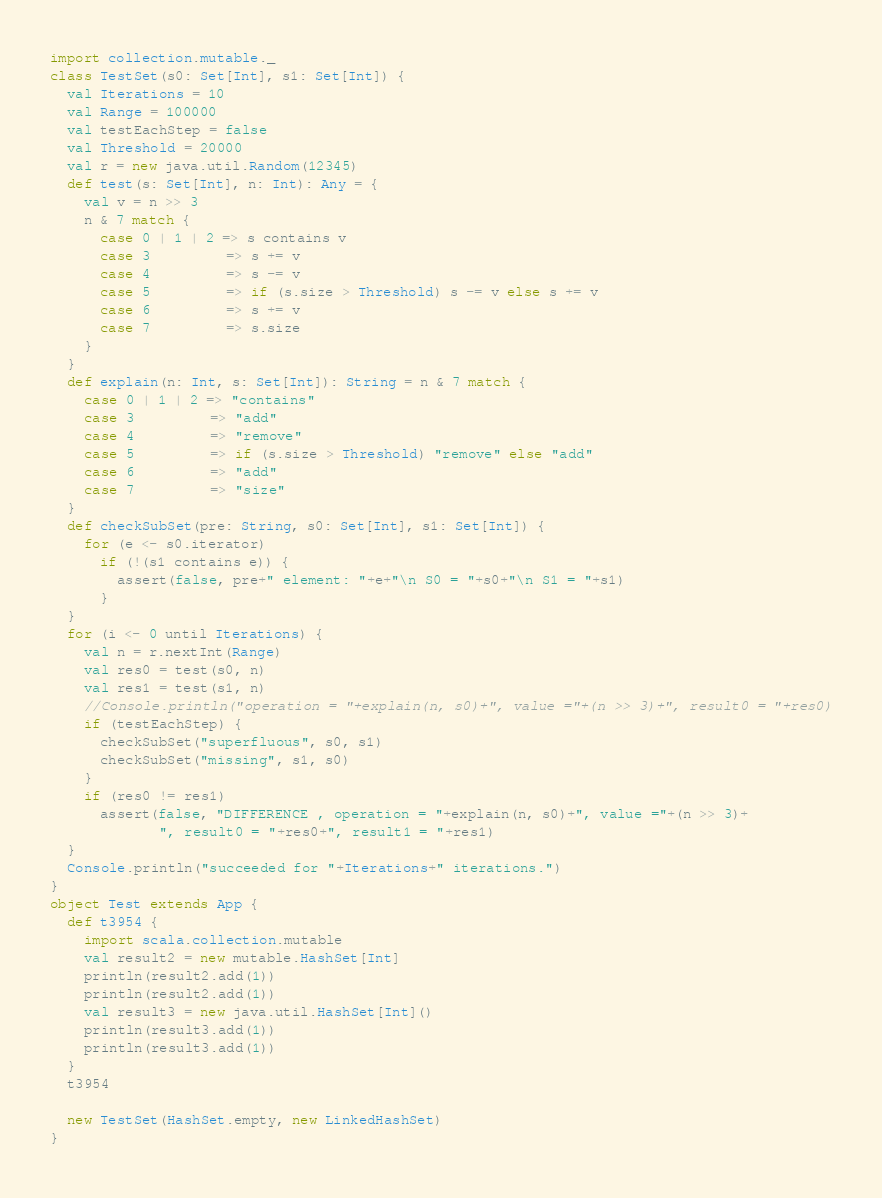<code> <loc_0><loc_0><loc_500><loc_500><_Scala_>import collection.mutable._
class TestSet(s0: Set[Int], s1: Set[Int]) {
  val Iterations = 10
  val Range = 100000
  val testEachStep = false
  val Threshold = 20000
  val r = new java.util.Random(12345)
  def test(s: Set[Int], n: Int): Any = {
    val v = n >> 3
    n & 7 match {
      case 0 | 1 | 2 => s contains v
      case 3         => s += v
      case 4         => s -= v
      case 5         => if (s.size > Threshold) s -= v else s += v
      case 6         => s += v
      case 7         => s.size
    }
  }
  def explain(n: Int, s: Set[Int]): String = n & 7 match {
    case 0 | 1 | 2 => "contains"
    case 3         => "add"
    case 4         => "remove"
    case 5         => if (s.size > Threshold) "remove" else "add"
    case 6         => "add"
    case 7         => "size"
  }
  def checkSubSet(pre: String, s0: Set[Int], s1: Set[Int]) {
    for (e <- s0.iterator)
      if (!(s1 contains e)) {
        assert(false, pre+" element: "+e+"\n S0 = "+s0+"\n S1 = "+s1)
      }
  }
  for (i <- 0 until Iterations) {
    val n = r.nextInt(Range)
    val res0 = test(s0, n)
    val res1 = test(s1, n)
    //Console.println("operation = "+explain(n, s0)+", value ="+(n >> 3)+", result0 = "+res0)
    if (testEachStep) {
      checkSubSet("superfluous", s0, s1)
      checkSubSet("missing", s1, s0)
    }
    if (res0 != res1)
      assert(false, "DIFFERENCE , operation = "+explain(n, s0)+", value ="+(n >> 3)+
             ", result0 = "+res0+", result1 = "+res1)
  }
  Console.println("succeeded for "+Iterations+" iterations.")
}
object Test extends App {
  def t3954 {
    import scala.collection.mutable
    val result2 = new mutable.HashSet[Int]
    println(result2.add(1))
    println(result2.add(1))
    val result3 = new java.util.HashSet[Int]()
    println(result3.add(1))
    println(result3.add(1))
  }
  t3954

  new TestSet(HashSet.empty, new LinkedHashSet)
}
</code> 